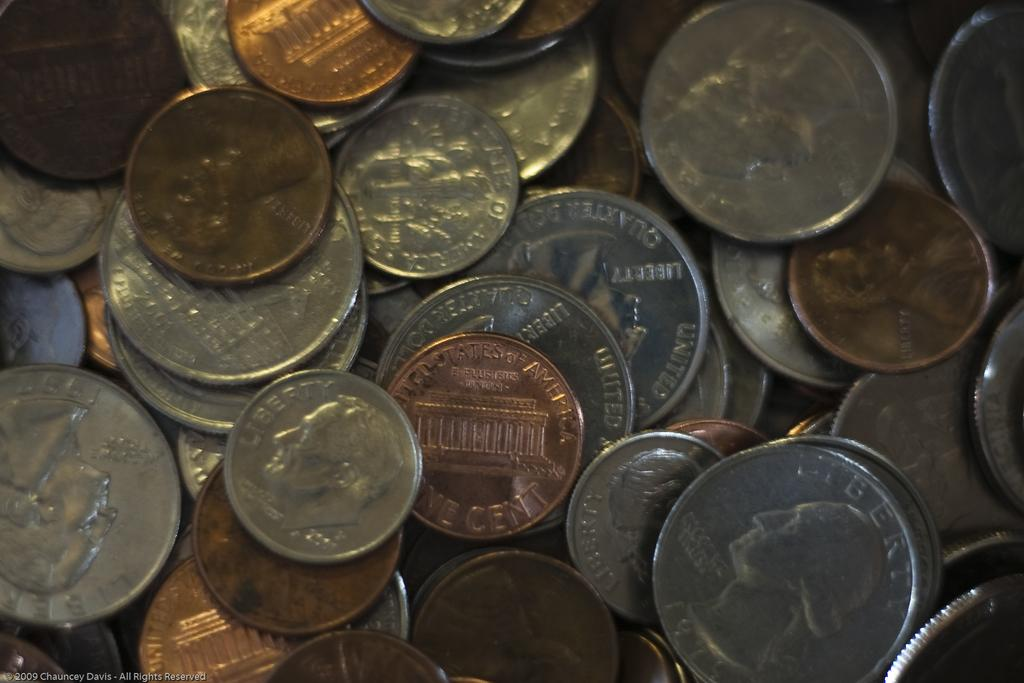Provide a one-sentence caption for the provided image. A pile of american change including a 2001 dime on the lower left. 